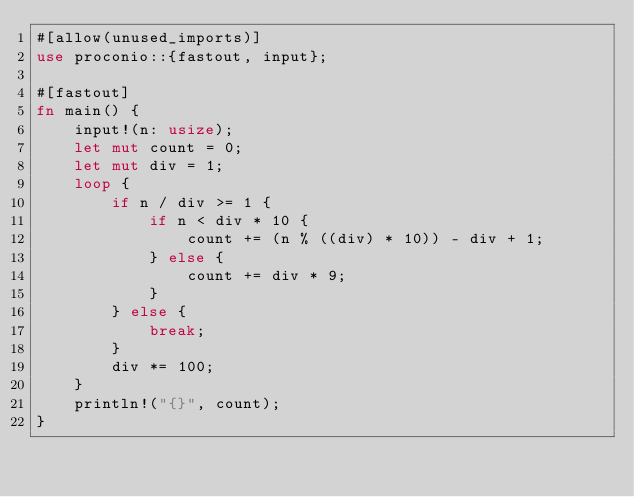<code> <loc_0><loc_0><loc_500><loc_500><_Rust_>#[allow(unused_imports)]
use proconio::{fastout, input};

#[fastout]
fn main() {
    input!(n: usize);
    let mut count = 0;
    let mut div = 1;
    loop {
        if n / div >= 1 {
            if n < div * 10 {
                count += (n % ((div) * 10)) - div + 1;
            } else {
                count += div * 9;
            }
        } else {
            break;
        }
        div *= 100;
    }
    println!("{}", count);
}
</code> 